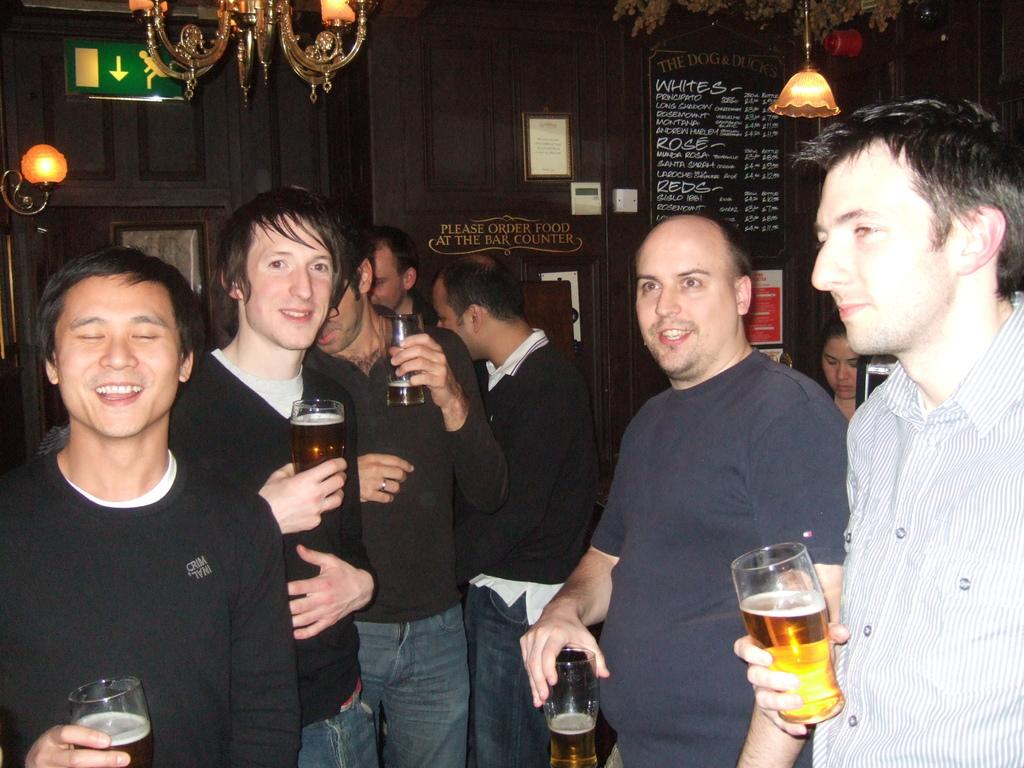How many people are present in the image? There are five people in the image. What are the people in the image doing? The people are having a drink. Can you describe the facial expression of one person in the image? One person on the left side is smiling. What type of canvas is being used by the people in the image? There is no canvas present in the image; the people are simply having a drink. Can you tell me the name of the person's partner in the image? There is no mention of a partner or relationship between the people in the image. 